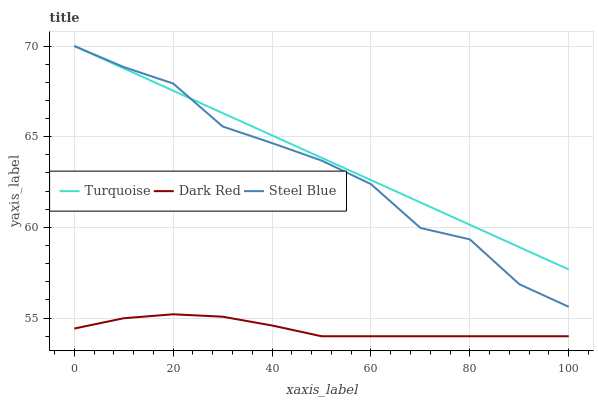Does Dark Red have the minimum area under the curve?
Answer yes or no. Yes. Does Turquoise have the maximum area under the curve?
Answer yes or no. Yes. Does Steel Blue have the minimum area under the curve?
Answer yes or no. No. Does Steel Blue have the maximum area under the curve?
Answer yes or no. No. Is Turquoise the smoothest?
Answer yes or no. Yes. Is Steel Blue the roughest?
Answer yes or no. Yes. Is Steel Blue the smoothest?
Answer yes or no. No. Is Turquoise the roughest?
Answer yes or no. No. Does Dark Red have the lowest value?
Answer yes or no. Yes. Does Steel Blue have the lowest value?
Answer yes or no. No. Does Steel Blue have the highest value?
Answer yes or no. Yes. Is Dark Red less than Turquoise?
Answer yes or no. Yes. Is Turquoise greater than Dark Red?
Answer yes or no. Yes. Does Steel Blue intersect Turquoise?
Answer yes or no. Yes. Is Steel Blue less than Turquoise?
Answer yes or no. No. Is Steel Blue greater than Turquoise?
Answer yes or no. No. Does Dark Red intersect Turquoise?
Answer yes or no. No. 